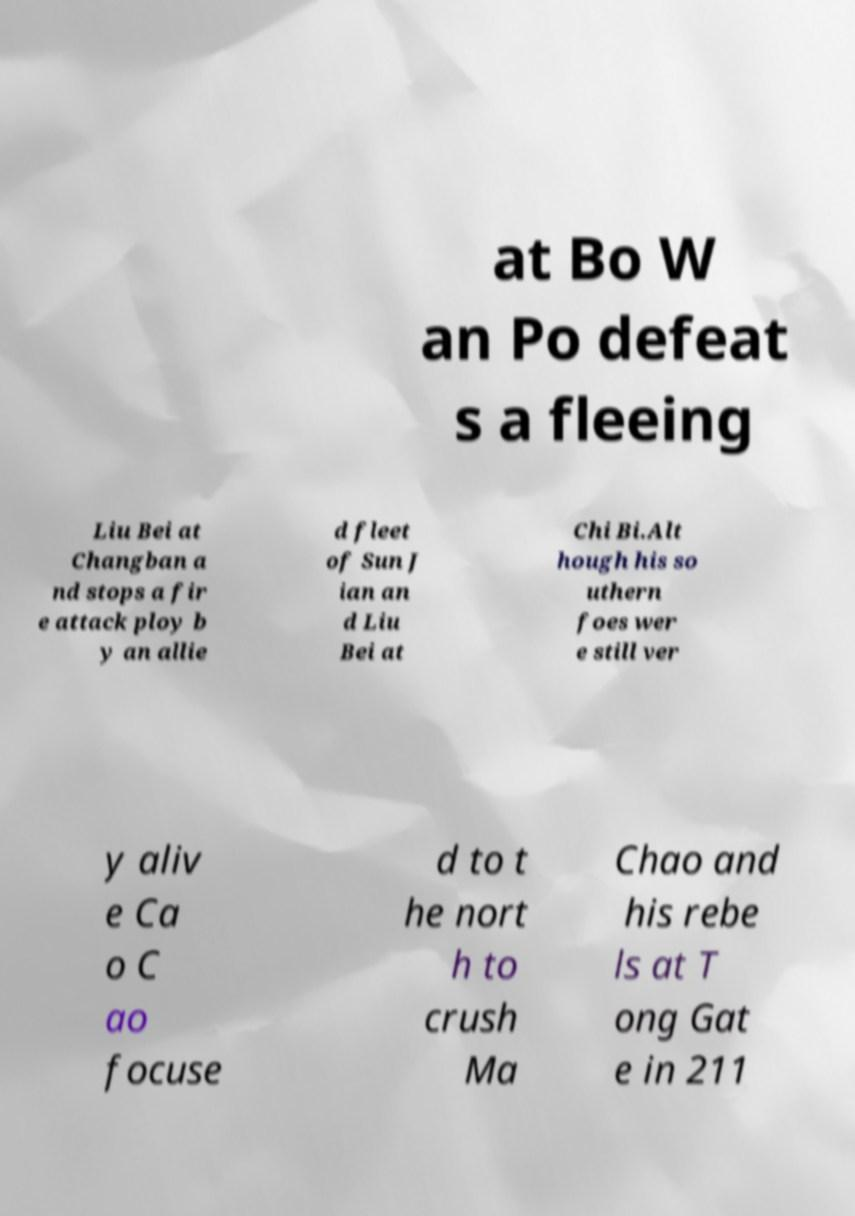I need the written content from this picture converted into text. Can you do that? at Bo W an Po defeat s a fleeing Liu Bei at Changban a nd stops a fir e attack ploy b y an allie d fleet of Sun J ian an d Liu Bei at Chi Bi.Alt hough his so uthern foes wer e still ver y aliv e Ca o C ao focuse d to t he nort h to crush Ma Chao and his rebe ls at T ong Gat e in 211 